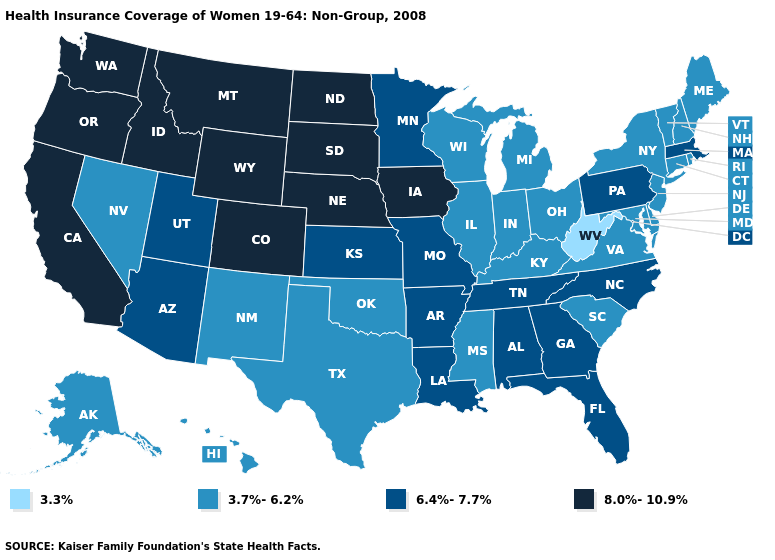Among the states that border Rhode Island , which have the lowest value?
Short answer required. Connecticut. Name the states that have a value in the range 3.3%?
Write a very short answer. West Virginia. What is the value of Hawaii?
Write a very short answer. 3.7%-6.2%. What is the highest value in the USA?
Write a very short answer. 8.0%-10.9%. Name the states that have a value in the range 3.3%?
Keep it brief. West Virginia. Which states have the lowest value in the Northeast?
Give a very brief answer. Connecticut, Maine, New Hampshire, New Jersey, New York, Rhode Island, Vermont. Among the states that border Montana , which have the lowest value?
Quick response, please. Idaho, North Dakota, South Dakota, Wyoming. Is the legend a continuous bar?
Quick response, please. No. Name the states that have a value in the range 8.0%-10.9%?
Be succinct. California, Colorado, Idaho, Iowa, Montana, Nebraska, North Dakota, Oregon, South Dakota, Washington, Wyoming. Name the states that have a value in the range 8.0%-10.9%?
Answer briefly. California, Colorado, Idaho, Iowa, Montana, Nebraska, North Dakota, Oregon, South Dakota, Washington, Wyoming. Among the states that border Maryland , which have the lowest value?
Short answer required. West Virginia. Which states have the lowest value in the USA?
Answer briefly. West Virginia. What is the value of New York?
Answer briefly. 3.7%-6.2%. What is the lowest value in states that border Florida?
Concise answer only. 6.4%-7.7%. Name the states that have a value in the range 3.7%-6.2%?
Write a very short answer. Alaska, Connecticut, Delaware, Hawaii, Illinois, Indiana, Kentucky, Maine, Maryland, Michigan, Mississippi, Nevada, New Hampshire, New Jersey, New Mexico, New York, Ohio, Oklahoma, Rhode Island, South Carolina, Texas, Vermont, Virginia, Wisconsin. 